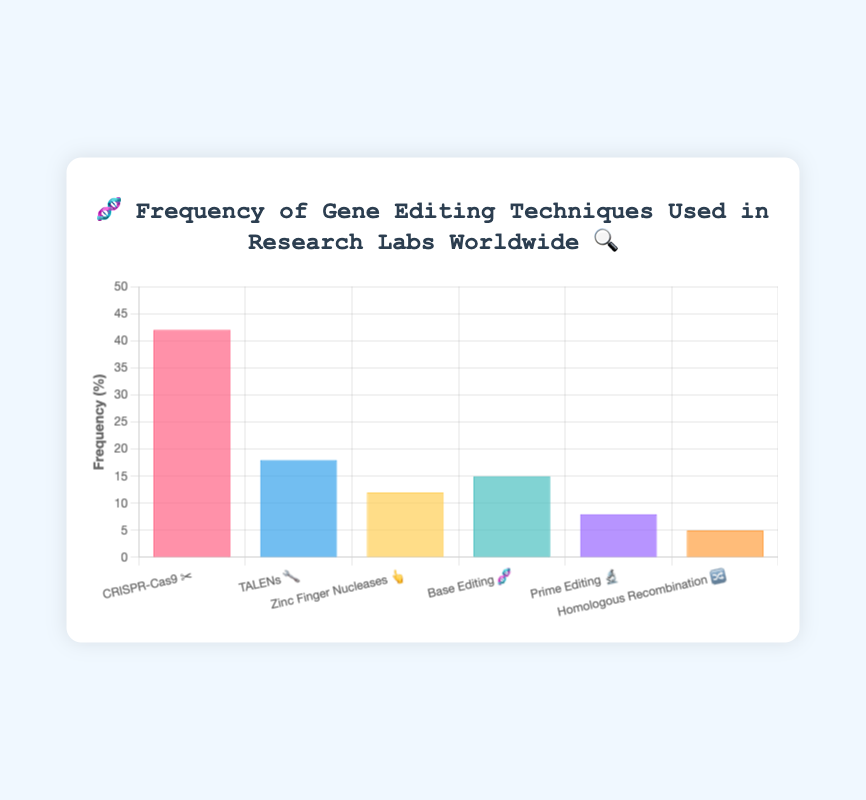What is the most frequently used gene editing technique in research labs worldwide? The most frequently used technique can be identified as the bar with the tallest height. In this case, the highest bar corresponds to CRISPR-Cas9 with a frequency of 42%.
Answer: CRISPR-Cas9 How many techniques have a frequency lower than 10%? Look at the bars with frequencies below 10%. Prime Editing (8%) and Homologous Recombination (5%) meet this criteria. Therefore, there are 2 techniques.
Answer: 2 What is the frequency difference between the techniques TALENs and Zinc Finger Nucleases? The frequency of TALENs is 18% and the frequency of Zinc Finger Nucleases is 12%. The difference is 18 - 12 = 6%.
Answer: 6% Which technique has the lowest frequency and what is its value? The shortest bar represents the technique with the lowest frequency, which is Homologous Recombination at 5%.
Answer: Homologous Recombination, 5% What is the cumulative frequency of Base Editing and Prime Editing? Base Editing has a frequency of 15% and Prime Editing has a frequency of 8%. Their cumulative frequency is 15 + 8 = 23%.
Answer: 23% Which technique uses the 🔧 emoji and what is its frequency? TALENs uses the 🔧 emoji and its corresponding bar shows a frequency of 18%.
Answer: TALENs, 18% What is the average frequency of all gene editing techniques listed? Sum the frequencies and divide by the number of techniques: (42 + 18 + 12 + 15 + 8 + 5) / 6 = 100 / 6 ≈ 16.67%.
Answer: 16.67% How many techniques have a frequency greater than Base Editing? Base Editing has a frequency of 15%. The techniques with frequencies greater than this are CRISPR-Cas9 (42%) and TALENs (18%), making a total of 2 techniques.
Answer: 2 What is the frequency range of the gene editing techniques? The range is calculated as the difference between the highest and lowest frequencies. The highest frequency is 42% (CRISPR-Cas9) and the lowest is 5% (Homologous Recombination). Therefore, the range is 42 - 5 = 37%.
Answer: 37% Which technique has a frequency exactly equal to its emoji presentation count in the chart labels? By checking each emoji, we see that Base Editing 🧬 has a frequency of 15%, and there is 1 emoji for Base Editing in the label. No other technique's frequency matches its emoji count.
Answer: Base Editing 